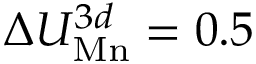Convert formula to latex. <formula><loc_0><loc_0><loc_500><loc_500>\Delta U _ { M n } ^ { 3 d } = 0 . 5</formula> 